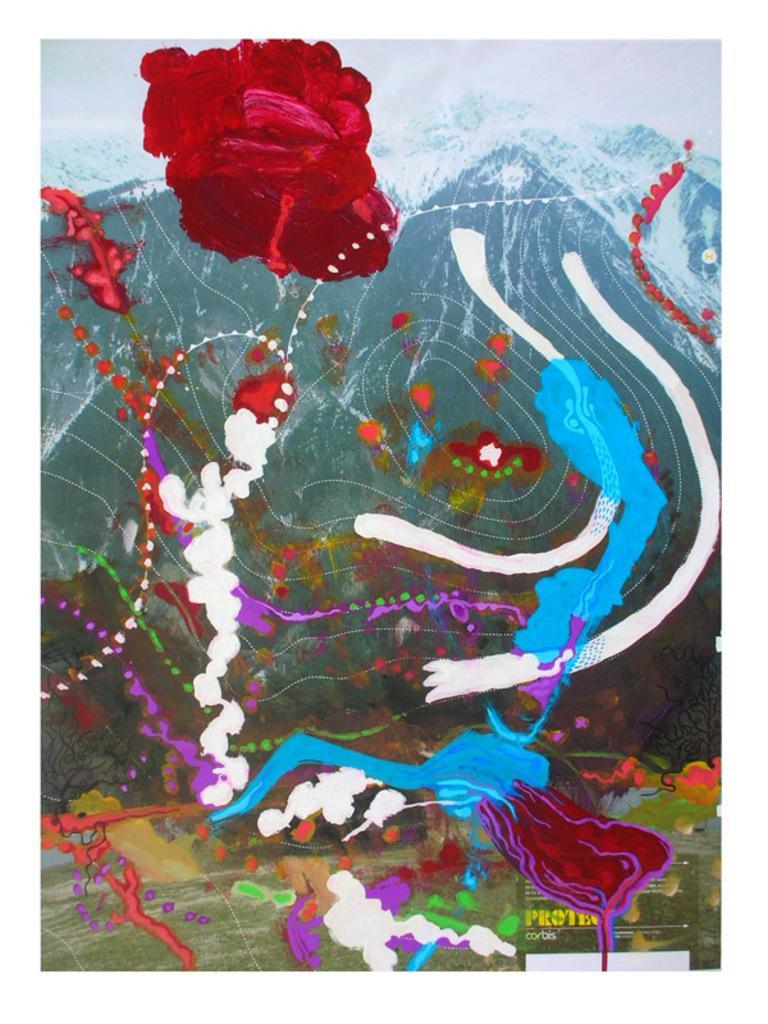Please provide a concise description of this image. In the image we can see there is a painting done on the poster and there are mountains in the poster. 